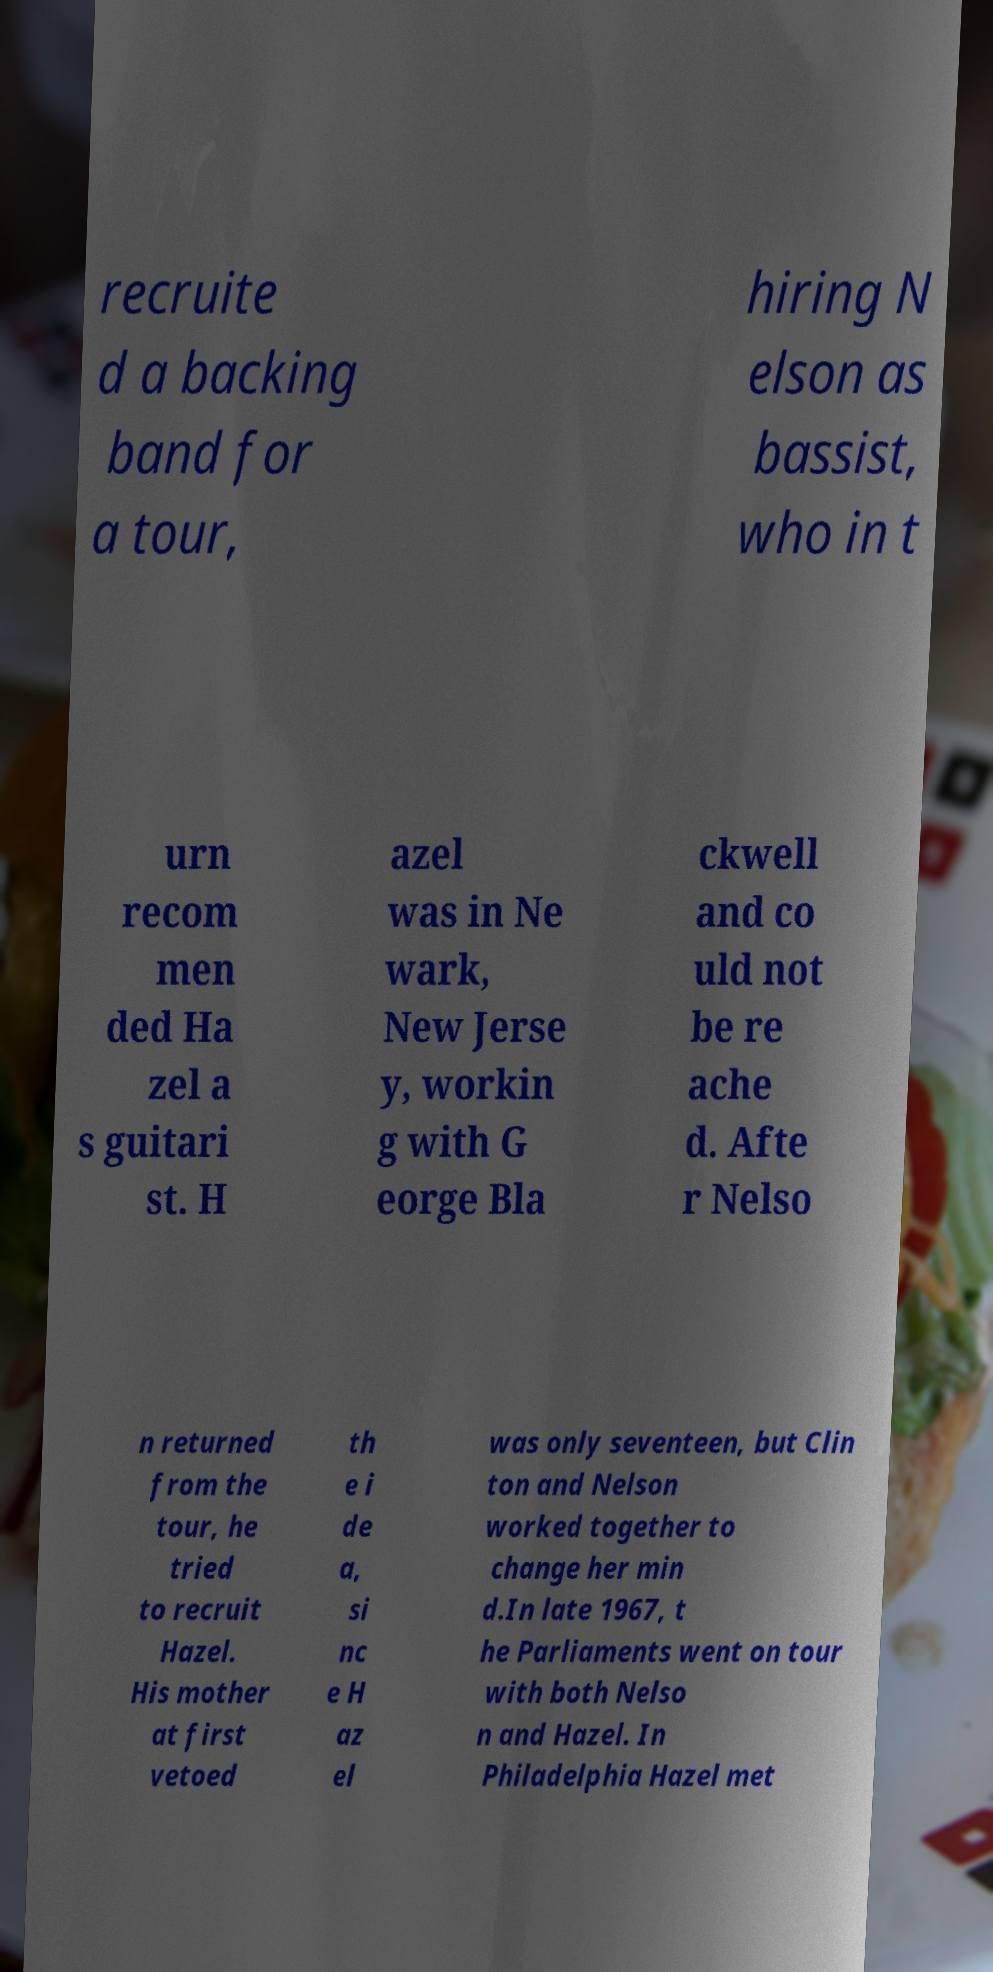Please read and relay the text visible in this image. What does it say? recruite d a backing band for a tour, hiring N elson as bassist, who in t urn recom men ded Ha zel a s guitari st. H azel was in Ne wark, New Jerse y, workin g with G eorge Bla ckwell and co uld not be re ache d. Afte r Nelso n returned from the tour, he tried to recruit Hazel. His mother at first vetoed th e i de a, si nc e H az el was only seventeen, but Clin ton and Nelson worked together to change her min d.In late 1967, t he Parliaments went on tour with both Nelso n and Hazel. In Philadelphia Hazel met 